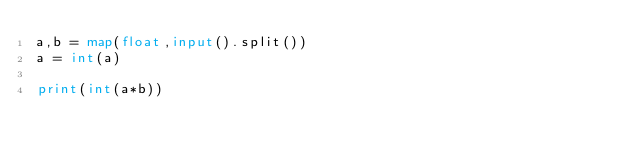<code> <loc_0><loc_0><loc_500><loc_500><_Python_>a,b = map(float,input().split())
a = int(a)

print(int(a*b))
</code> 